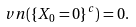<formula> <loc_0><loc_0><loc_500><loc_500>\ v n ( \{ X _ { 0 } = 0 \} ^ { c } ) = 0 .</formula> 